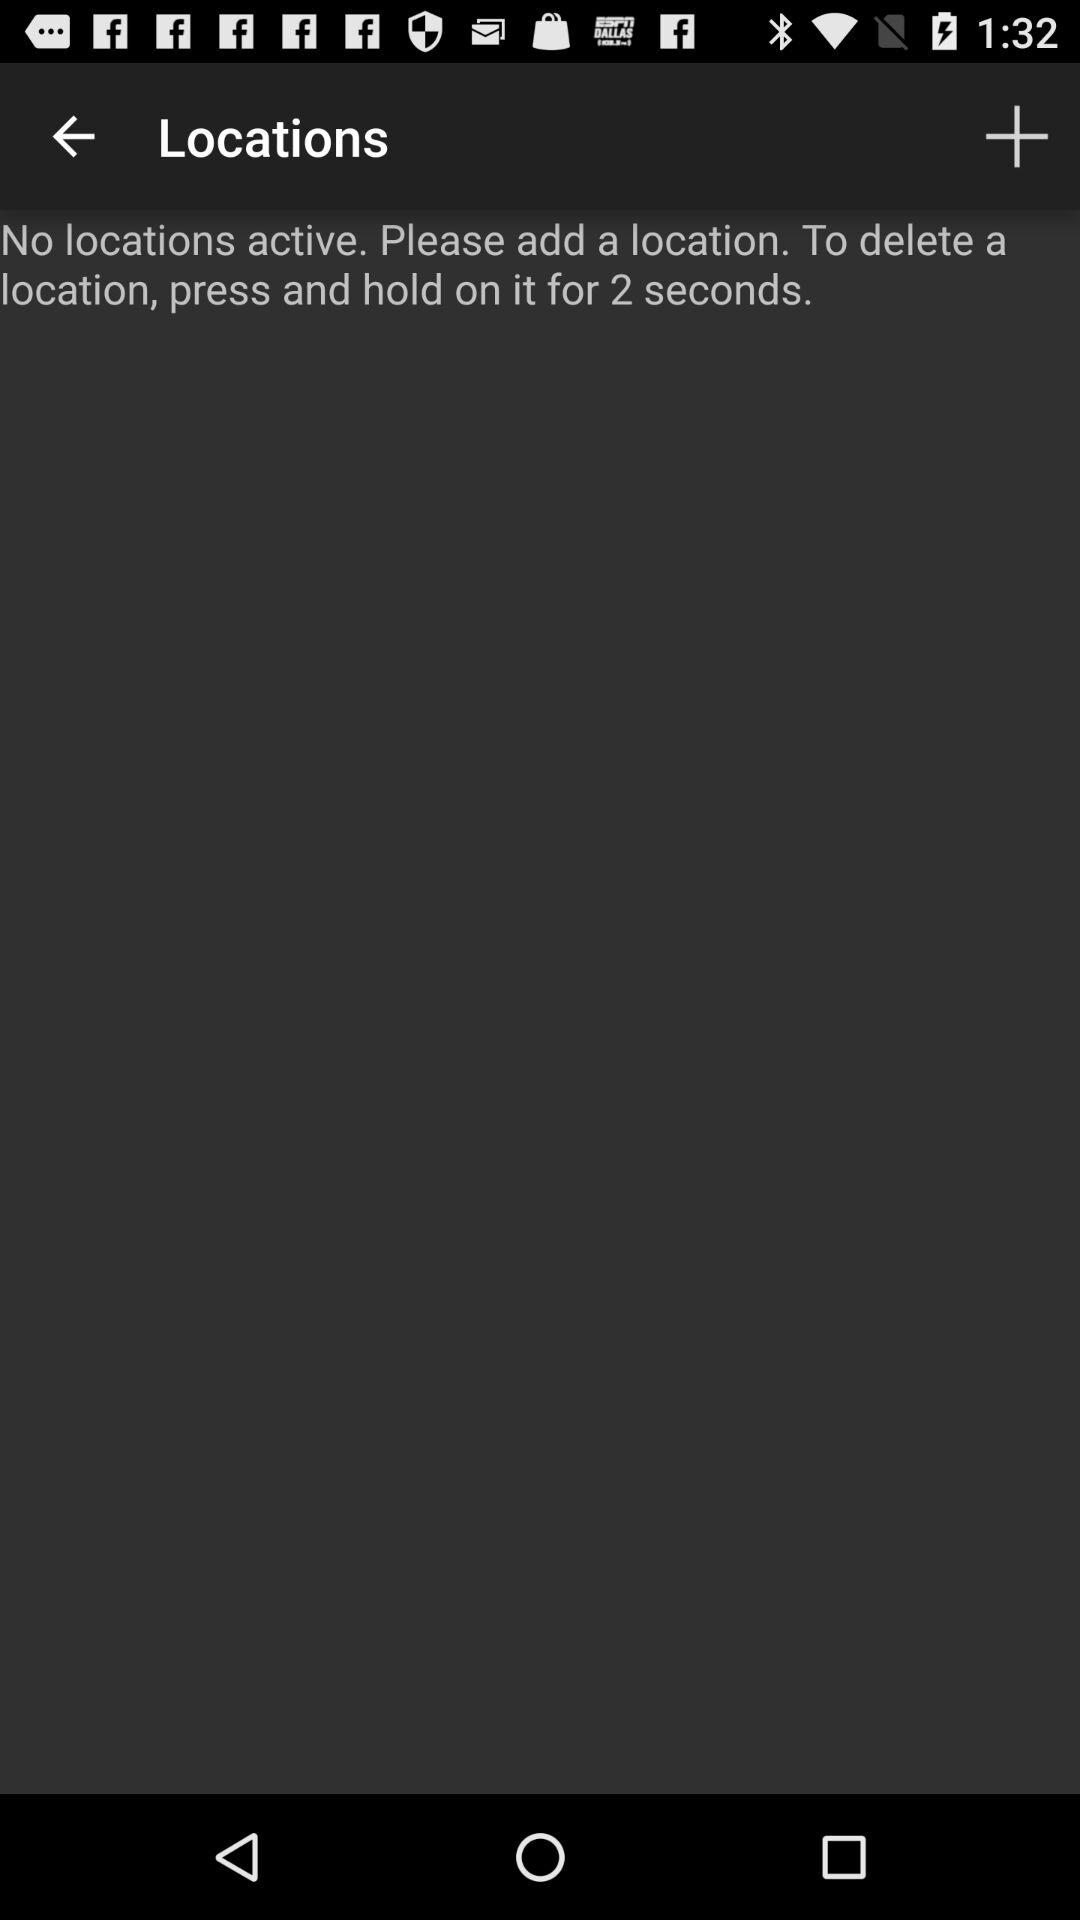How many more seconds do you need to hold a location to delete it than to add it?
Answer the question using a single word or phrase. 2 